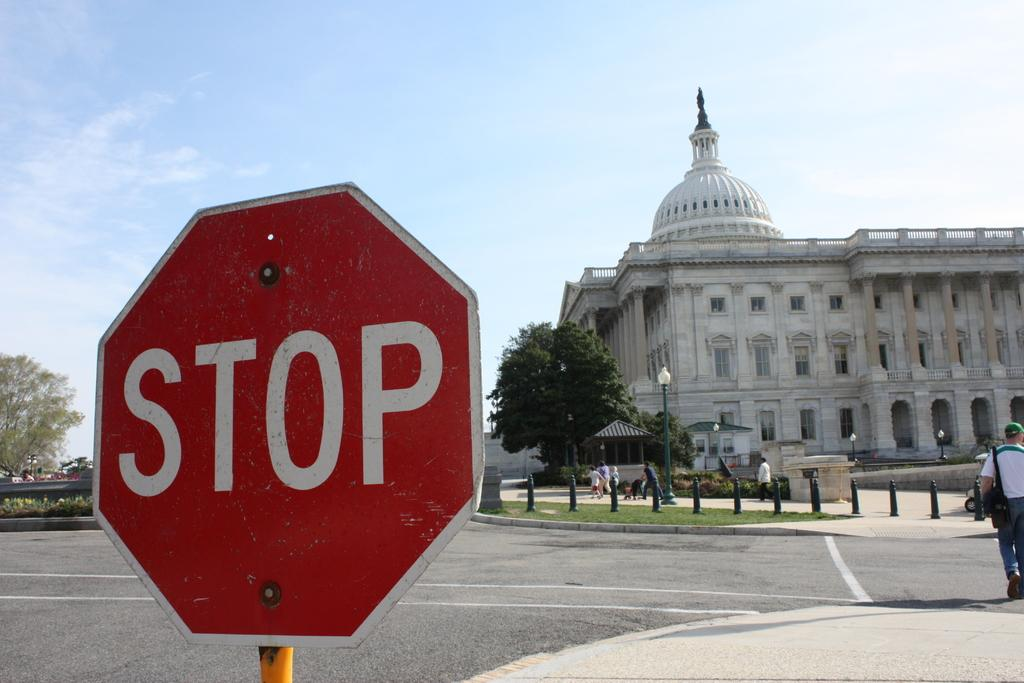<image>
Share a concise interpretation of the image provided. A stop sign with the United States Capitol building in the background 